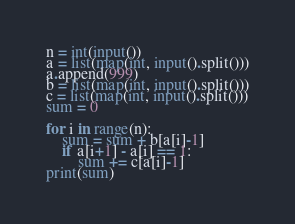<code> <loc_0><loc_0><loc_500><loc_500><_Python_>n = int(input())
a = list(map(int, input().split()))
a.append(999)
b = list(map(int, input().split()))
c = list(map(int, input().split()))
sum = 0

for i in range(n):
    sum = sum + b[a[i]-1]
    if a[i+1] - a[i] == 1:
        sum += c[a[i]-1]
print(sum)</code> 